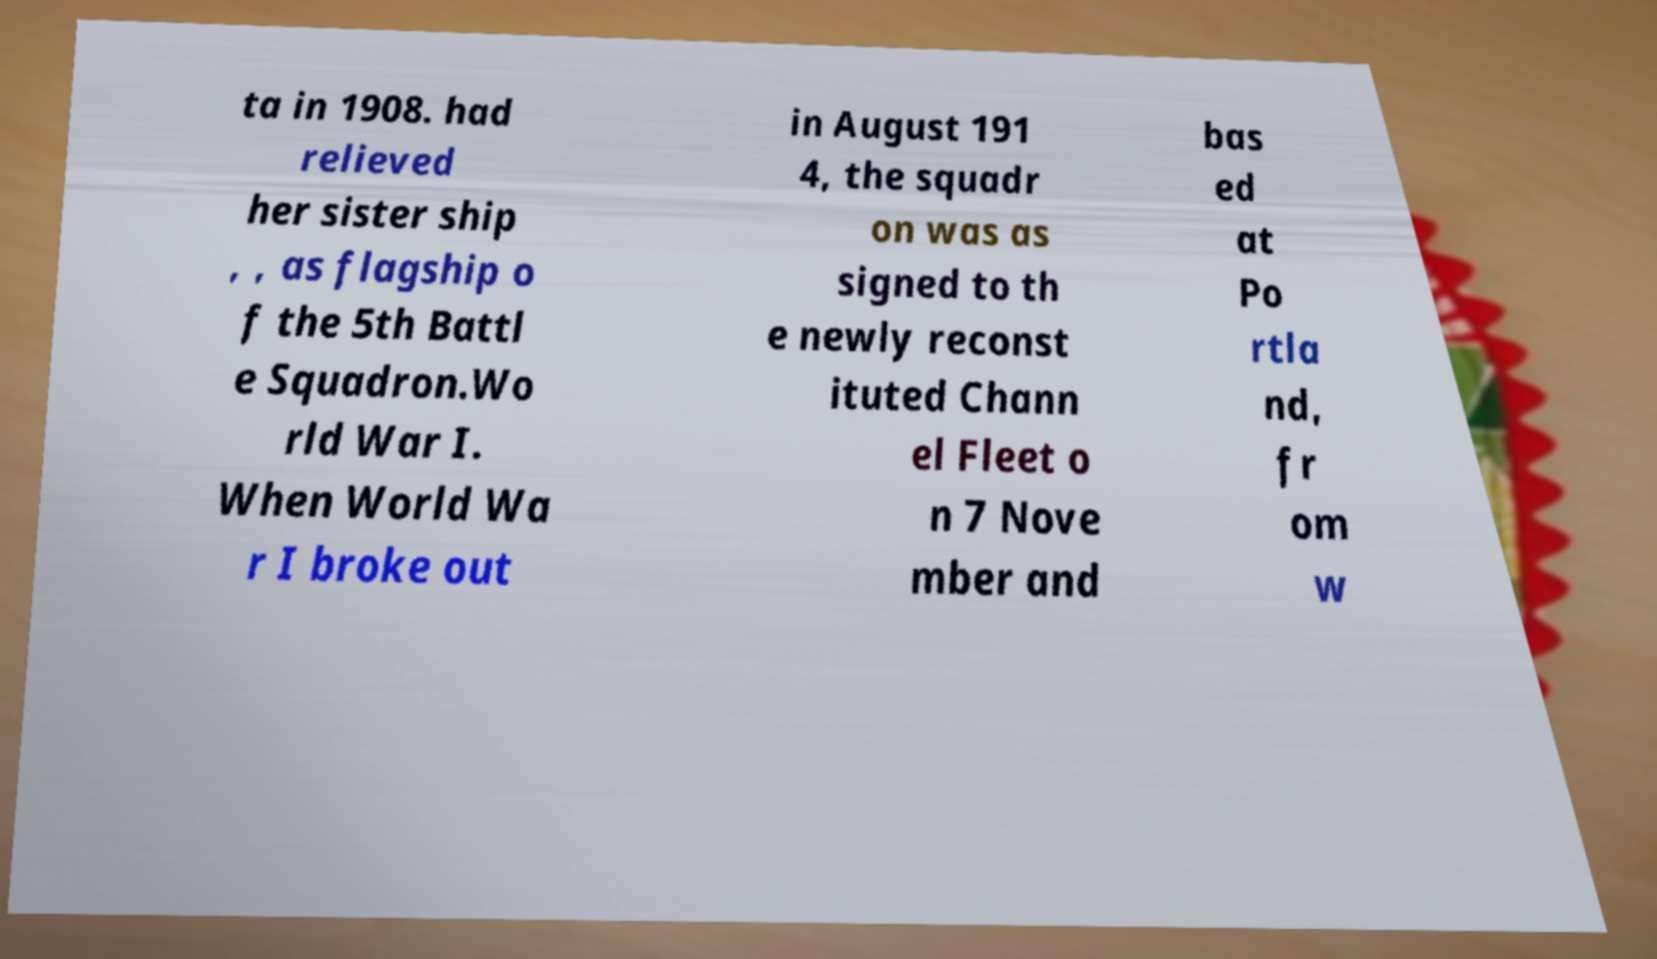Could you assist in decoding the text presented in this image and type it out clearly? ta in 1908. had relieved her sister ship , , as flagship o f the 5th Battl e Squadron.Wo rld War I. When World Wa r I broke out in August 191 4, the squadr on was as signed to th e newly reconst ituted Chann el Fleet o n 7 Nove mber and bas ed at Po rtla nd, fr om w 